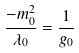Convert formula to latex. <formula><loc_0><loc_0><loc_500><loc_500>\frac { - m _ { 0 } ^ { 2 } } { \lambda _ { 0 } } = \frac { 1 } { g _ { 0 } }</formula> 